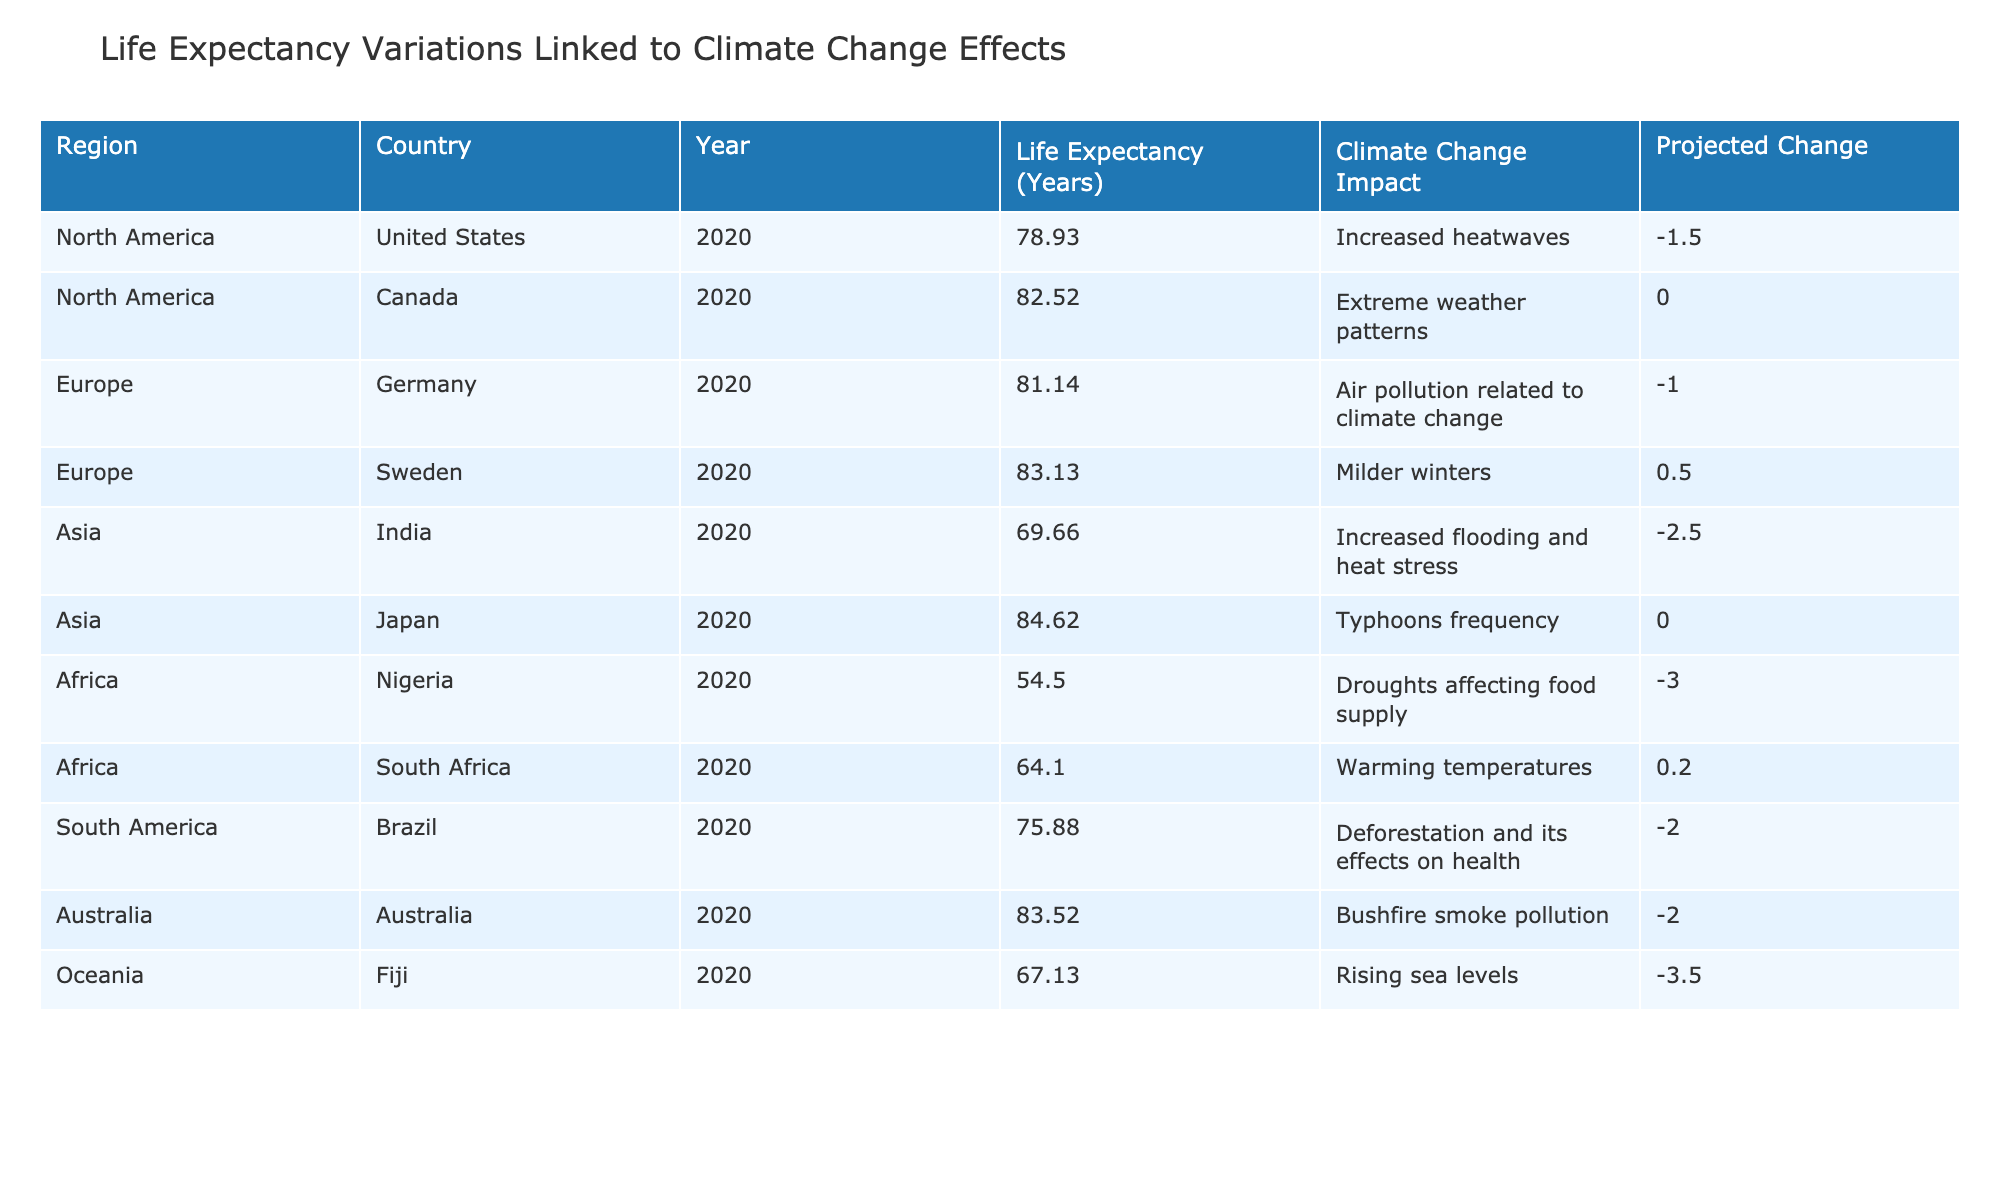What is the life expectancy of Canada for the year 2020? The table shows the life expectancy for Canada in 2020 as 82.52 years.
Answer: 82.52 Which region has the lowest life expectancy in 2020? By examining the life expectancy values, Nigeria has the lowest life expectancy at 54.5 years among the listed countries.
Answer: Nigeria What is the projected change in life expectancy for India due to climate change impacts? The table indicates that the projected change in life expectancy for India is -2.5 years due to increased flooding and heat stress.
Answer: -2.5 Is the life expectancy in Japan expected to increase or decrease in 2020? The life expectancy in Japan is listed as 84.62 years, with a projected change of 0.0 years, indicating that it is expected to remain stable, neither increasing nor decreasing.
Answer: No change Calculate the average life expectancy for countries in South America in 2020. There is one country listed from South America, Brazil, with a life expectancy of 75.88 years. Thus, the average is also 75.88 since there's only one data point.
Answer: 75.88 Which countries in Africa have a projected change in life expectancy that is positive? South Africa has a projected change of +0.2 years, which is the only positive value among the African countries listed, while Nigeria has a -3.0 year change.
Answer: South Africa What is the overall impact of climate change on life expectancy in North America as reported? In the United States, the impact is a decrease of -1.5 years, while Canada shows no change (0.0 years). Therefore, the overall impact for North America is a negative change when considering only the US.
Answer: Negative change Which country has a projected life expectancy of 67.13 years, and what climate change impact does it face? Fiji has a life expectancy of 67.13 years and faces the impact of rising sea levels.
Answer: Fiji, rising sea levels 